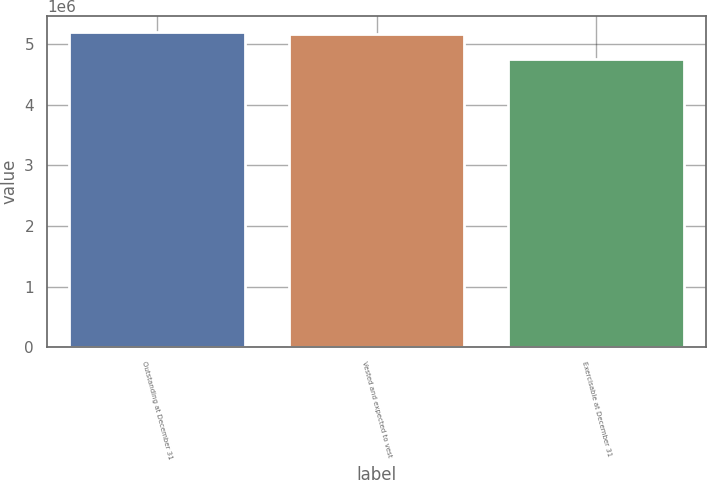<chart> <loc_0><loc_0><loc_500><loc_500><bar_chart><fcel>Outstanding at December 31<fcel>Vested and expected to vest<fcel>Exercisable at December 31<nl><fcel>5.2043e+06<fcel>5.15918e+06<fcel>4.74747e+06<nl></chart> 